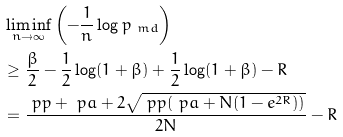<formula> <loc_0><loc_0><loc_500><loc_500>& \liminf _ { n \rightarrow \infty } \left ( - \frac { 1 } { n } \log p _ { \ m d } \right ) \\ & \geq \frac { \beta } { 2 } - \frac { 1 } { 2 } \log ( 1 + \beta ) + \frac { 1 } { 2 } \log ( 1 + \beta ) - R \\ & = \frac { \ p p + \ p a + 2 \sqrt { \ p p ( \ p a + N ( 1 - e ^ { 2 R } ) ) } } { 2 N } - R</formula> 